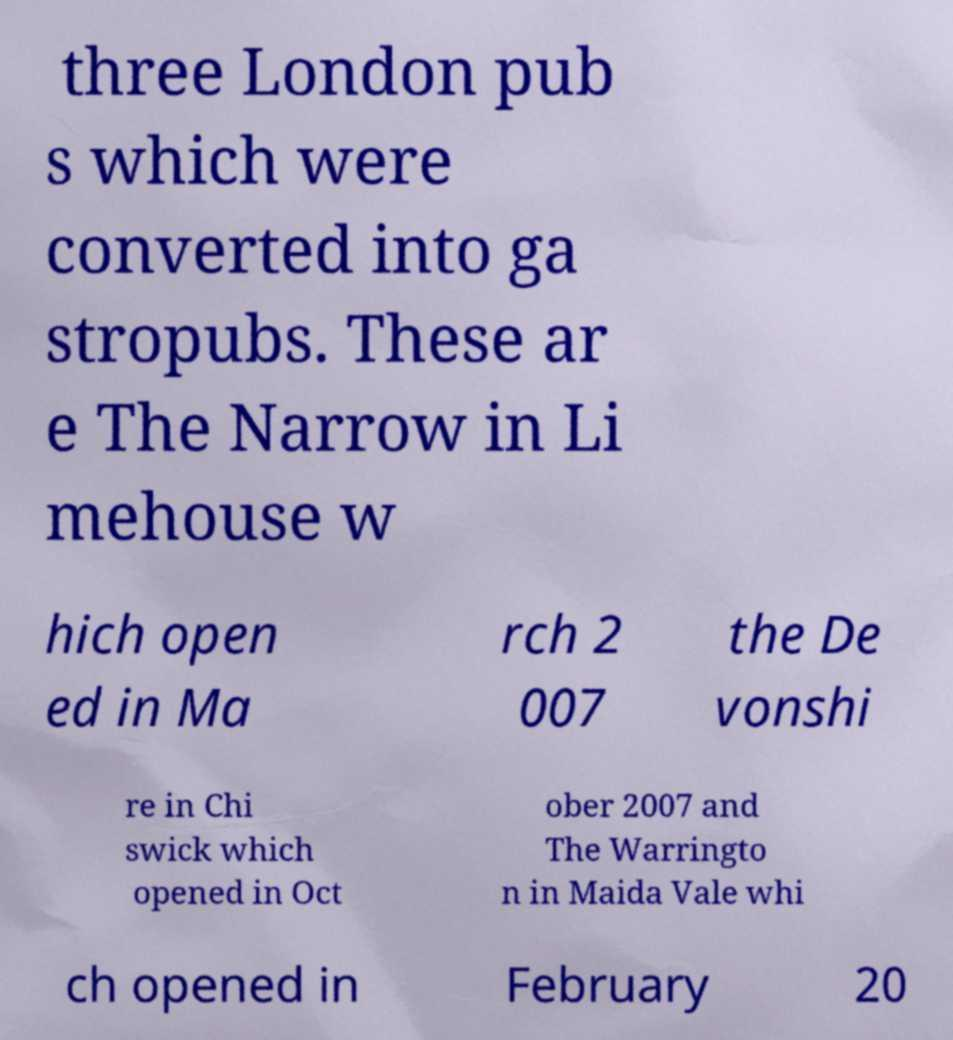Please identify and transcribe the text found in this image. three London pub s which were converted into ga stropubs. These ar e The Narrow in Li mehouse w hich open ed in Ma rch 2 007 the De vonshi re in Chi swick which opened in Oct ober 2007 and The Warringto n in Maida Vale whi ch opened in February 20 